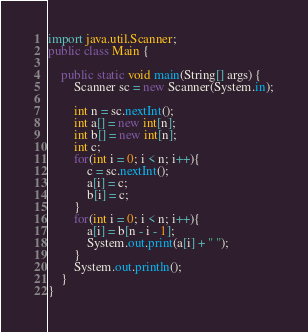Convert code to text. <code><loc_0><loc_0><loc_500><loc_500><_Java_>import java.util.Scanner;
public class Main {

    public static void main(String[] args) {
        Scanner sc = new Scanner(System.in);

        int n = sc.nextInt();
        int a[] = new int[n];
        int b[] = new int[n];
        int c;
        for(int i = 0; i < n; i++){
        	c = sc.nextInt();
        	a[i] = c;
        	b[i] = c;
        }
        for(int i = 0; i < n; i++){
        	a[i] = b[n - i - 1];
        	System.out.print(a[i] + " ");
        }
        System.out.println();
    }
}
</code> 